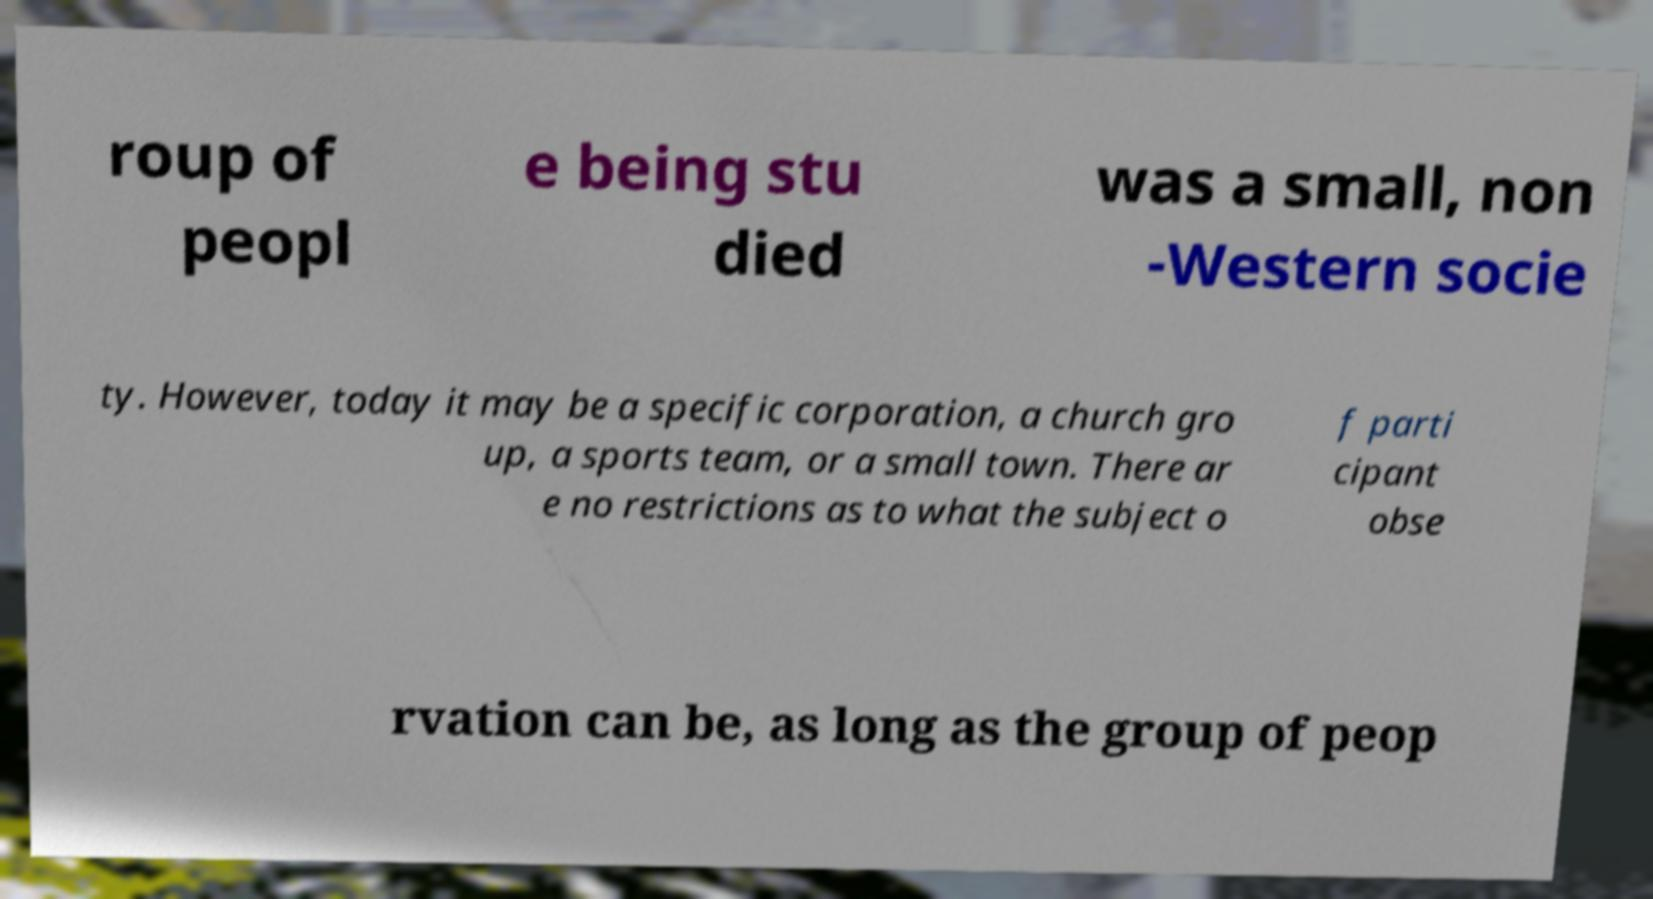Could you extract and type out the text from this image? roup of peopl e being stu died was a small, non -Western socie ty. However, today it may be a specific corporation, a church gro up, a sports team, or a small town. There ar e no restrictions as to what the subject o f parti cipant obse rvation can be, as long as the group of peop 